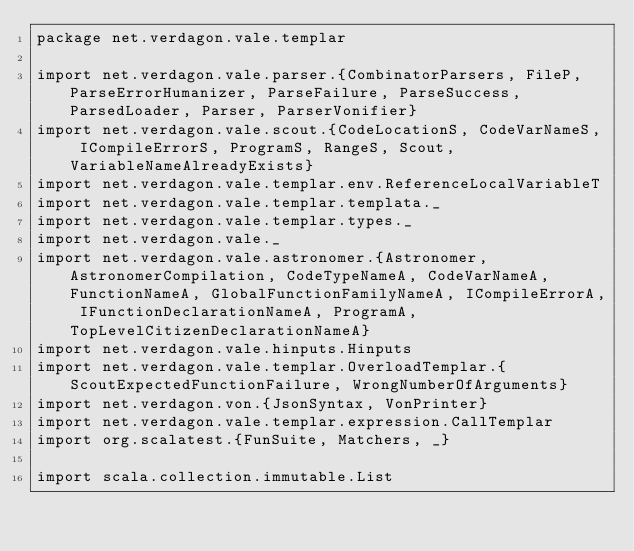<code> <loc_0><loc_0><loc_500><loc_500><_Scala_>package net.verdagon.vale.templar

import net.verdagon.vale.parser.{CombinatorParsers, FileP, ParseErrorHumanizer, ParseFailure, ParseSuccess, ParsedLoader, Parser, ParserVonifier}
import net.verdagon.vale.scout.{CodeLocationS, CodeVarNameS, ICompileErrorS, ProgramS, RangeS, Scout, VariableNameAlreadyExists}
import net.verdagon.vale.templar.env.ReferenceLocalVariableT
import net.verdagon.vale.templar.templata._
import net.verdagon.vale.templar.types._
import net.verdagon.vale._
import net.verdagon.vale.astronomer.{Astronomer, AstronomerCompilation, CodeTypeNameA, CodeVarNameA, FunctionNameA, GlobalFunctionFamilyNameA, ICompileErrorA, IFunctionDeclarationNameA, ProgramA, TopLevelCitizenDeclarationNameA}
import net.verdagon.vale.hinputs.Hinputs
import net.verdagon.vale.templar.OverloadTemplar.{ScoutExpectedFunctionFailure, WrongNumberOfArguments}
import net.verdagon.von.{JsonSyntax, VonPrinter}
import net.verdagon.vale.templar.expression.CallTemplar
import org.scalatest.{FunSuite, Matchers, _}

import scala.collection.immutable.List</code> 